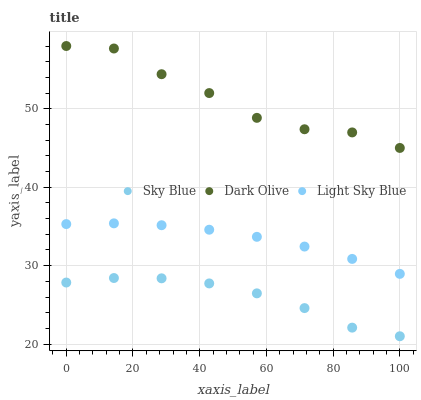Does Sky Blue have the minimum area under the curve?
Answer yes or no. Yes. Does Dark Olive have the maximum area under the curve?
Answer yes or no. Yes. Does Light Sky Blue have the minimum area under the curve?
Answer yes or no. No. Does Light Sky Blue have the maximum area under the curve?
Answer yes or no. No. Is Light Sky Blue the smoothest?
Answer yes or no. Yes. Is Dark Olive the roughest?
Answer yes or no. Yes. Is Dark Olive the smoothest?
Answer yes or no. No. Is Light Sky Blue the roughest?
Answer yes or no. No. Does Sky Blue have the lowest value?
Answer yes or no. Yes. Does Light Sky Blue have the lowest value?
Answer yes or no. No. Does Dark Olive have the highest value?
Answer yes or no. Yes. Does Light Sky Blue have the highest value?
Answer yes or no. No. Is Sky Blue less than Dark Olive?
Answer yes or no. Yes. Is Light Sky Blue greater than Sky Blue?
Answer yes or no. Yes. Does Sky Blue intersect Dark Olive?
Answer yes or no. No. 